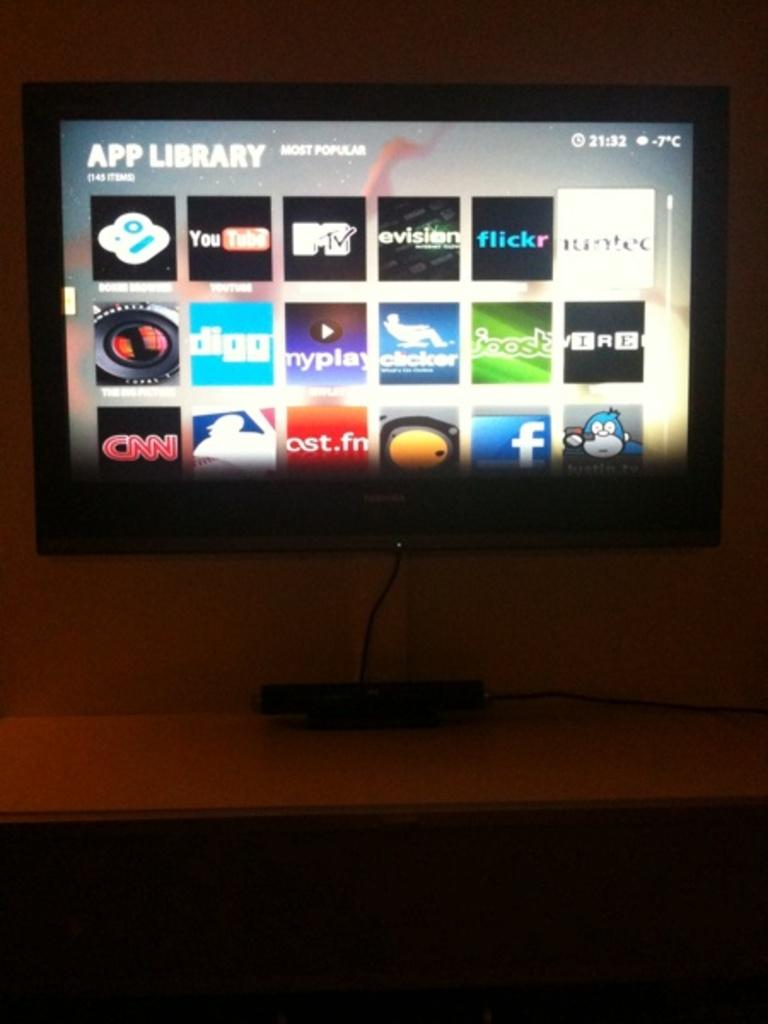<image>
Offer a succinct explanation of the picture presented. A screen of an App Library includes apps for YouTube, Wired, Facebook, and others. 